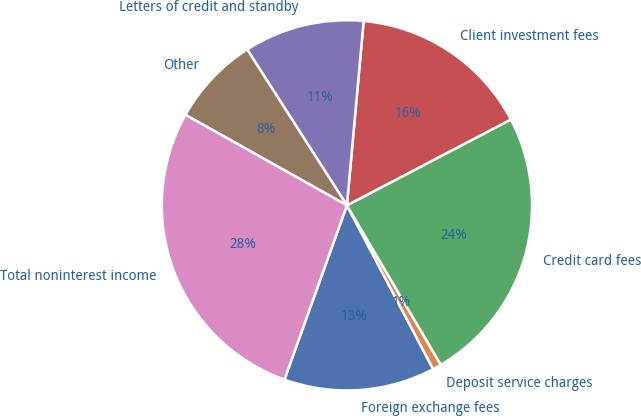<chart> <loc_0><loc_0><loc_500><loc_500><pie_chart><fcel>Foreign exchange fees<fcel>Deposit service charges<fcel>Credit card fees<fcel>Client investment fees<fcel>Letters of credit and standby<fcel>Other<fcel>Total noninterest income<nl><fcel>13.19%<fcel>0.76%<fcel>24.2%<fcel>15.88%<fcel>10.5%<fcel>7.81%<fcel>27.65%<nl></chart> 